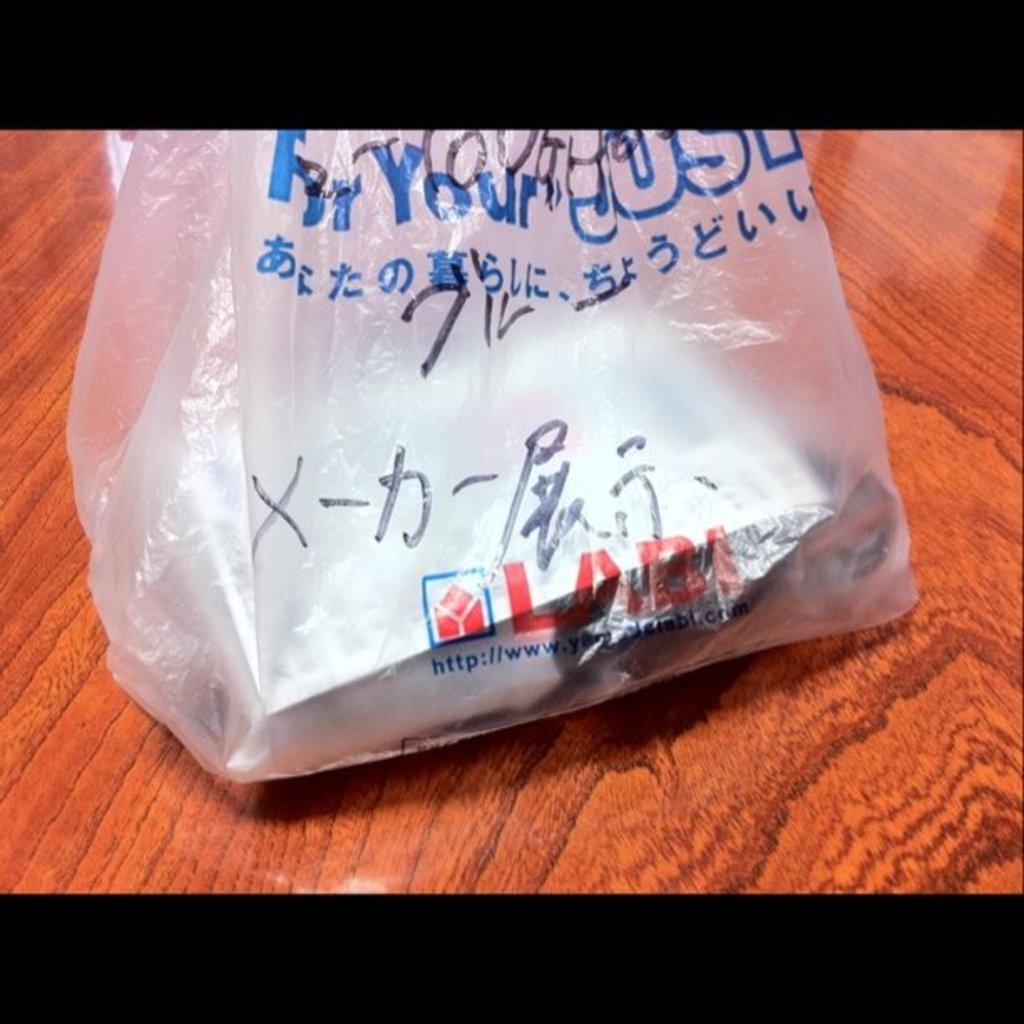Can you describe this image briefly? In this image I can see the brown colored table and on it I can see a plastic cover with few objects in it and I can see something is written on the cover. 